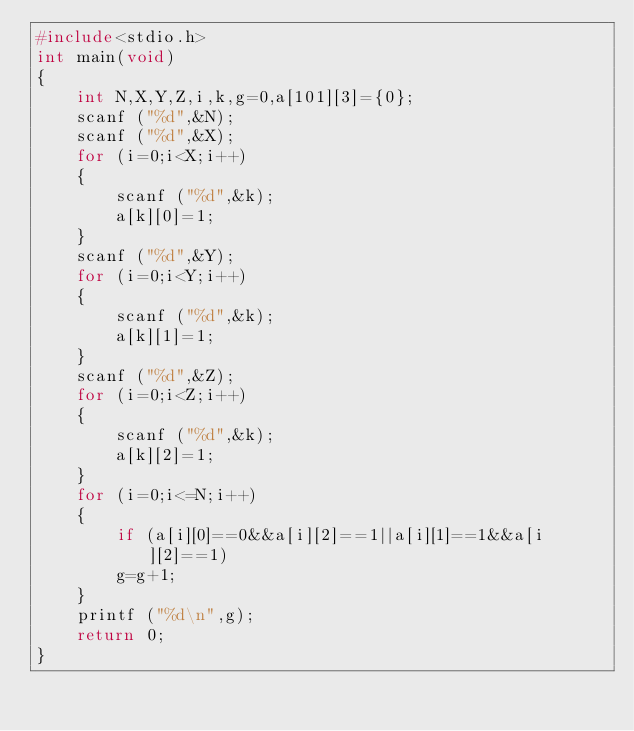<code> <loc_0><loc_0><loc_500><loc_500><_C_>#include<stdio.h>
int main(void)
{
	int N,X,Y,Z,i,k,g=0,a[101][3]={0};
	scanf ("%d",&N);
	scanf ("%d",&X);
	for (i=0;i<X;i++)
	{
		scanf ("%d",&k);
		a[k][0]=1;
	}
	scanf ("%d",&Y);
	for (i=0;i<Y;i++)
	{
		scanf ("%d",&k);
		a[k][1]=1;
	}
	scanf ("%d",&Z);
	for (i=0;i<Z;i++)
	{
		scanf ("%d",&k);
		a[k][2]=1;
	}
	for (i=0;i<=N;i++)
	{
		if (a[i][0]==0&&a[i][2]==1||a[i][1]==1&&a[i][2]==1)
		g=g+1;
	}
	printf ("%d\n",g);
	return 0;
}</code> 